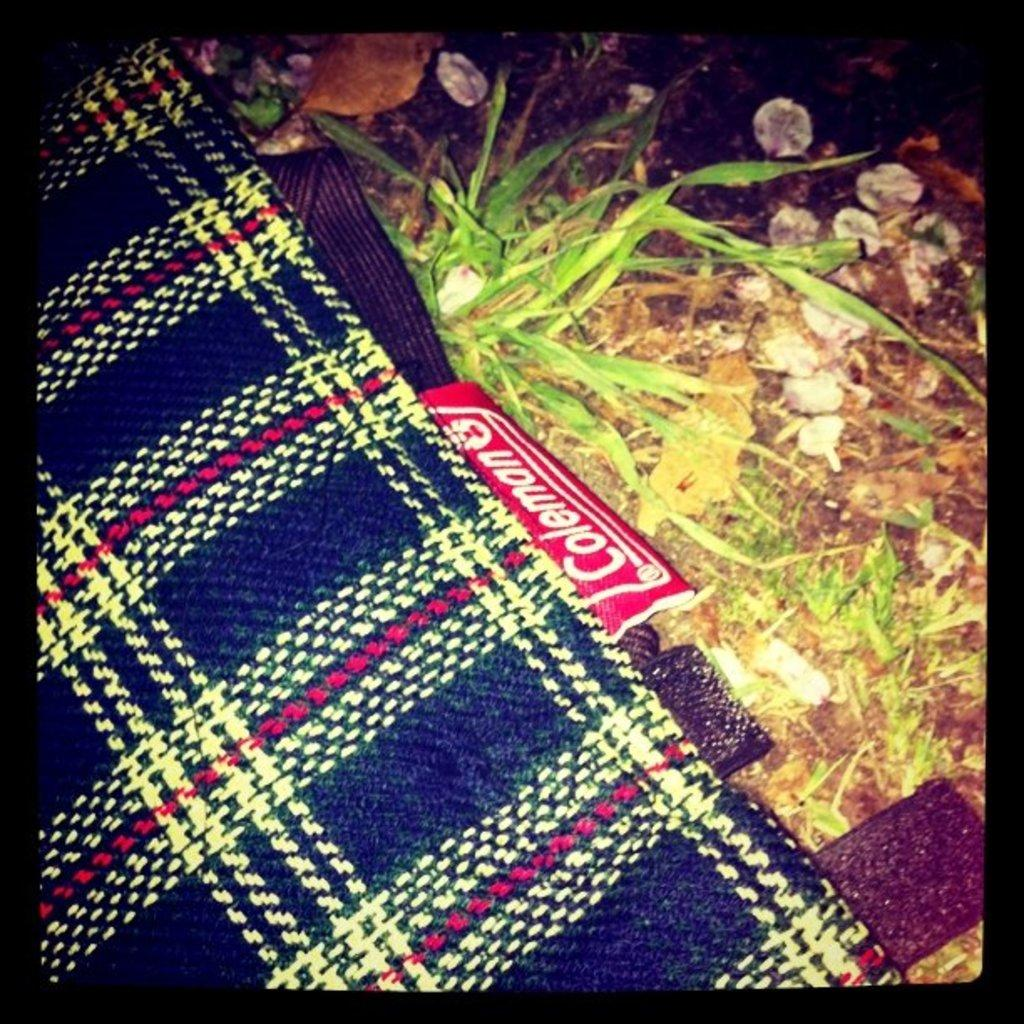What color is the blanket in the image? The blanket in the image is blue. What can be seen beneath the blanket? The ground is visible in the image. What type of vegetation is present on the ground? There is grass on the ground. What else is present on the ground besides grass? There are stones on the ground. What type of hammer is being used to create friction in the image? There is no hammer or friction present in the image. 